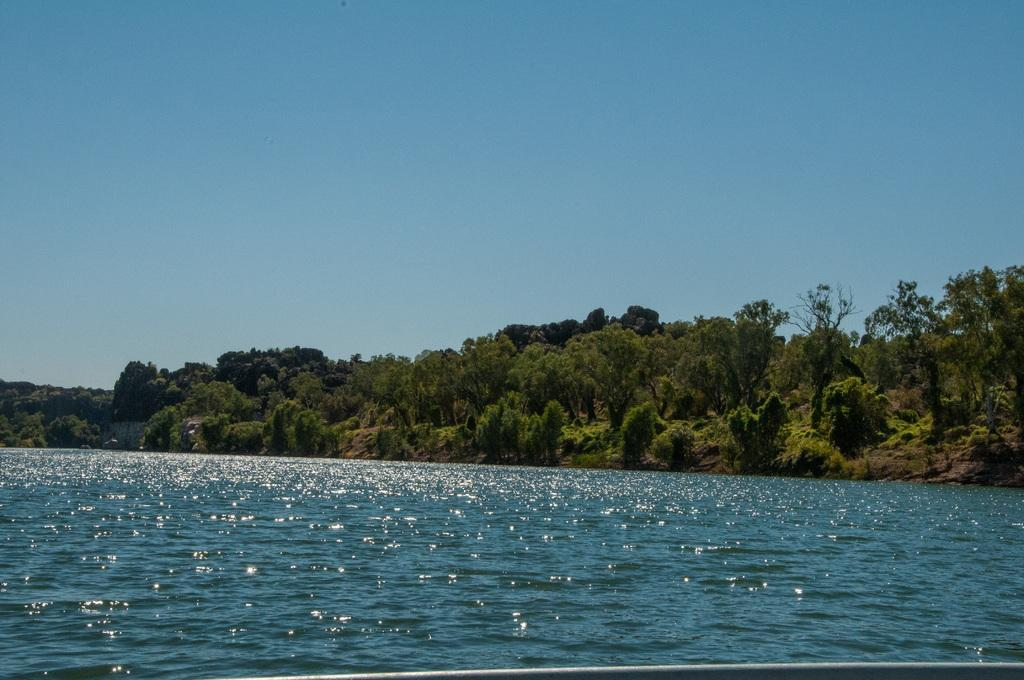What can be seen in the sky in the image? The sky is visible in the image. What type of natural features are present in the image? There are trees, hills, and a lake in the image. How many lizards can be seen crawling on the wall in the image? There is no wall or lizards present in the image. What type of pollution is visible in the image? There is no pollution visible in the image; it features natural elements such as the sky, trees, hills, and a lake. 